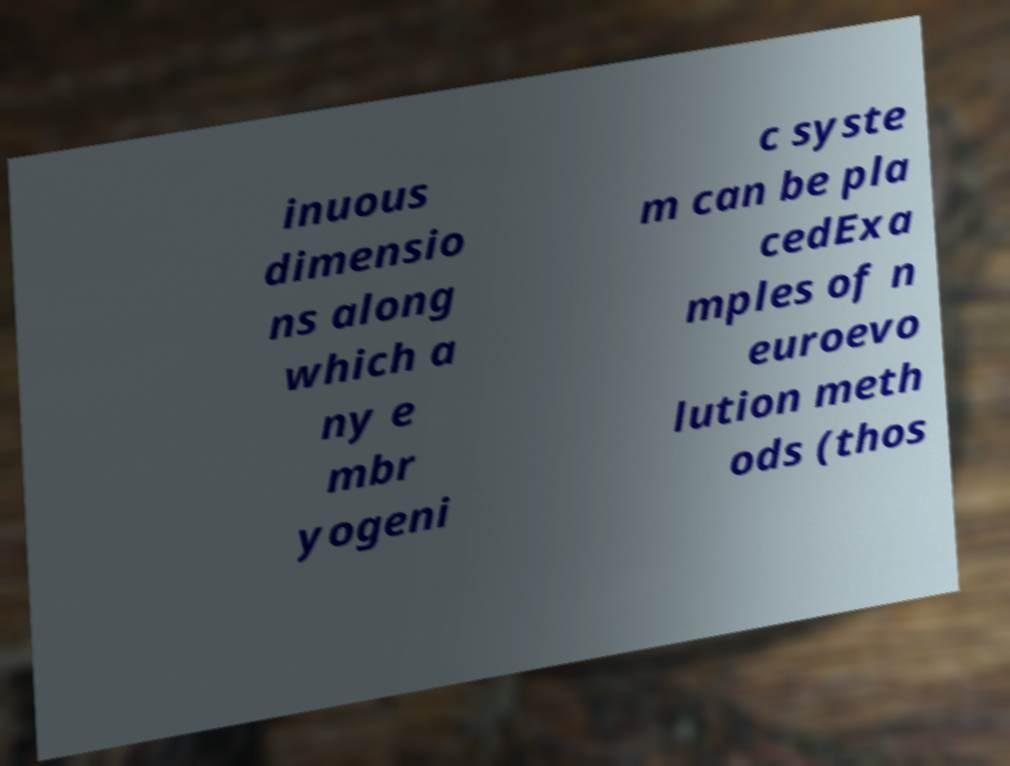For documentation purposes, I need the text within this image transcribed. Could you provide that? inuous dimensio ns along which a ny e mbr yogeni c syste m can be pla cedExa mples of n euroevo lution meth ods (thos 